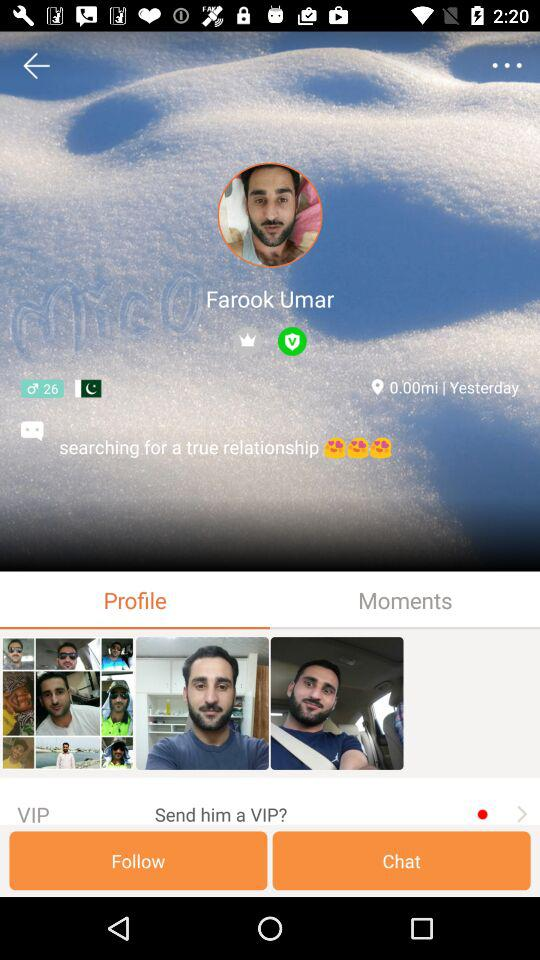What is the user name? The user name is Farook Umar. 